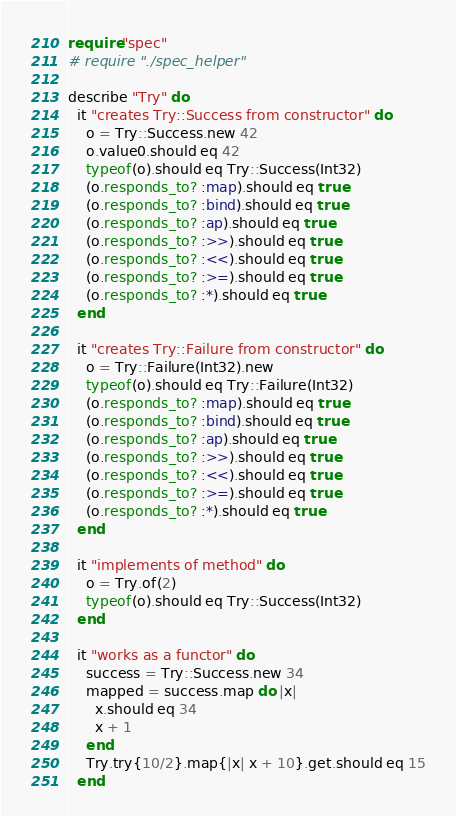<code> <loc_0><loc_0><loc_500><loc_500><_Crystal_>require "spec"
# require "./spec_helper"

describe "Try" do
  it "creates Try::Success from constructor" do
    o = Try::Success.new 42
    o.value0.should eq 42
    typeof(o).should eq Try::Success(Int32)
    (o.responds_to? :map).should eq true
    (o.responds_to? :bind).should eq true
    (o.responds_to? :ap).should eq true
    (o.responds_to? :>>).should eq true
    (o.responds_to? :<<).should eq true
    (o.responds_to? :>=).should eq true
    (o.responds_to? :*).should eq true
  end

  it "creates Try::Failure from constructor" do
    o = Try::Failure(Int32).new
    typeof(o).should eq Try::Failure(Int32)
    (o.responds_to? :map).should eq true
    (o.responds_to? :bind).should eq true
    (o.responds_to? :ap).should eq true
    (o.responds_to? :>>).should eq true
    (o.responds_to? :<<).should eq true
    (o.responds_to? :>=).should eq true
    (o.responds_to? :*).should eq true
  end

  it "implements of method" do
    o = Try.of(2)
    typeof(o).should eq Try::Success(Int32)
  end

  it "works as a functor" do
    success = Try::Success.new 34
    mapped = success.map do |x|
      x.should eq 34
      x + 1
    end
    Try.try{10/2}.map{|x| x + 10}.get.should eq 15
  end
</code> 